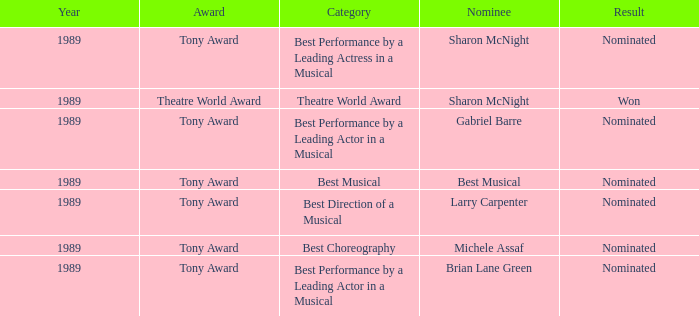What was the nominee of best musical Best Musical. 